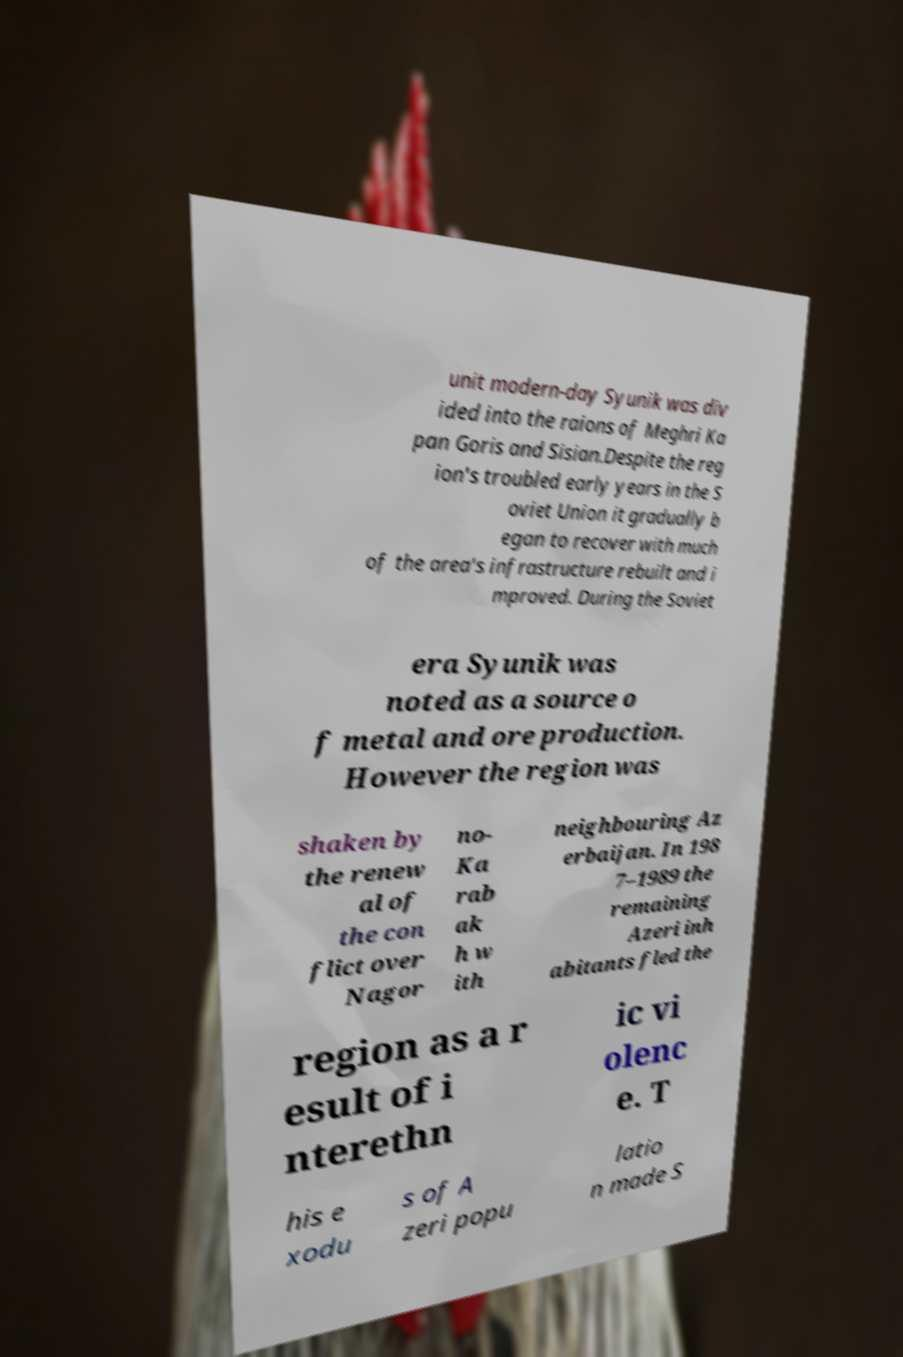There's text embedded in this image that I need extracted. Can you transcribe it verbatim? unit modern-day Syunik was div ided into the raions of Meghri Ka pan Goris and Sisian.Despite the reg ion's troubled early years in the S oviet Union it gradually b egan to recover with much of the area's infrastructure rebuilt and i mproved. During the Soviet era Syunik was noted as a source o f metal and ore production. However the region was shaken by the renew al of the con flict over Nagor no- Ka rab ak h w ith neighbouring Az erbaijan. In 198 7–1989 the remaining Azeri inh abitants fled the region as a r esult of i nterethn ic vi olenc e. T his e xodu s of A zeri popu latio n made S 